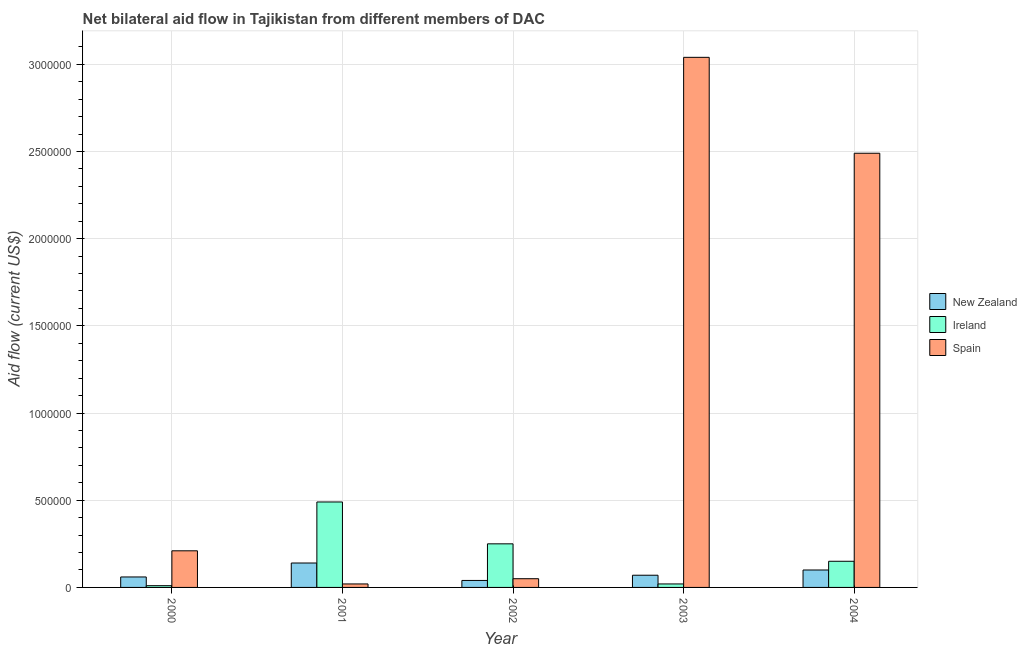Are the number of bars per tick equal to the number of legend labels?
Provide a short and direct response. Yes. Are the number of bars on each tick of the X-axis equal?
Your response must be concise. Yes. How many bars are there on the 5th tick from the right?
Your answer should be very brief. 3. What is the amount of aid provided by new zealand in 2000?
Provide a short and direct response. 6.00e+04. Across all years, what is the maximum amount of aid provided by ireland?
Provide a succinct answer. 4.90e+05. Across all years, what is the minimum amount of aid provided by spain?
Make the answer very short. 2.00e+04. In which year was the amount of aid provided by spain maximum?
Keep it short and to the point. 2003. What is the total amount of aid provided by new zealand in the graph?
Your answer should be very brief. 4.10e+05. What is the difference between the amount of aid provided by spain in 2003 and that in 2004?
Offer a terse response. 5.50e+05. What is the difference between the amount of aid provided by ireland in 2004 and the amount of aid provided by spain in 2002?
Provide a succinct answer. -1.00e+05. What is the average amount of aid provided by new zealand per year?
Your answer should be compact. 8.20e+04. In the year 2003, what is the difference between the amount of aid provided by new zealand and amount of aid provided by ireland?
Offer a very short reply. 0. What is the ratio of the amount of aid provided by spain in 2000 to that in 2004?
Ensure brevity in your answer.  0.08. Is the amount of aid provided by ireland in 2003 less than that in 2004?
Your answer should be compact. Yes. What is the difference between the highest and the lowest amount of aid provided by ireland?
Provide a succinct answer. 4.80e+05. Is the sum of the amount of aid provided by new zealand in 2002 and 2004 greater than the maximum amount of aid provided by spain across all years?
Provide a succinct answer. No. What does the 1st bar from the left in 2003 represents?
Your answer should be very brief. New Zealand. What does the 1st bar from the right in 2004 represents?
Provide a short and direct response. Spain. Is it the case that in every year, the sum of the amount of aid provided by new zealand and amount of aid provided by ireland is greater than the amount of aid provided by spain?
Your answer should be very brief. No. How many years are there in the graph?
Ensure brevity in your answer.  5. Does the graph contain any zero values?
Provide a short and direct response. No. Does the graph contain grids?
Provide a succinct answer. Yes. Where does the legend appear in the graph?
Keep it short and to the point. Center right. How are the legend labels stacked?
Offer a very short reply. Vertical. What is the title of the graph?
Ensure brevity in your answer.  Net bilateral aid flow in Tajikistan from different members of DAC. Does "Errors" appear as one of the legend labels in the graph?
Provide a short and direct response. No. What is the label or title of the X-axis?
Offer a terse response. Year. What is the label or title of the Y-axis?
Your answer should be very brief. Aid flow (current US$). What is the Aid flow (current US$) of New Zealand in 2000?
Provide a short and direct response. 6.00e+04. What is the Aid flow (current US$) of Spain in 2000?
Make the answer very short. 2.10e+05. What is the Aid flow (current US$) in New Zealand in 2001?
Ensure brevity in your answer.  1.40e+05. What is the Aid flow (current US$) of Ireland in 2001?
Give a very brief answer. 4.90e+05. What is the Aid flow (current US$) of Spain in 2001?
Your answer should be very brief. 2.00e+04. What is the Aid flow (current US$) of Ireland in 2003?
Offer a terse response. 2.00e+04. What is the Aid flow (current US$) in Spain in 2003?
Provide a short and direct response. 3.04e+06. What is the Aid flow (current US$) of New Zealand in 2004?
Your answer should be compact. 1.00e+05. What is the Aid flow (current US$) of Spain in 2004?
Keep it short and to the point. 2.49e+06. Across all years, what is the maximum Aid flow (current US$) of New Zealand?
Offer a terse response. 1.40e+05. Across all years, what is the maximum Aid flow (current US$) of Ireland?
Ensure brevity in your answer.  4.90e+05. Across all years, what is the maximum Aid flow (current US$) of Spain?
Give a very brief answer. 3.04e+06. Across all years, what is the minimum Aid flow (current US$) of New Zealand?
Your answer should be very brief. 4.00e+04. Across all years, what is the minimum Aid flow (current US$) in Spain?
Make the answer very short. 2.00e+04. What is the total Aid flow (current US$) in Ireland in the graph?
Make the answer very short. 9.20e+05. What is the total Aid flow (current US$) of Spain in the graph?
Give a very brief answer. 5.81e+06. What is the difference between the Aid flow (current US$) of New Zealand in 2000 and that in 2001?
Your answer should be very brief. -8.00e+04. What is the difference between the Aid flow (current US$) of Ireland in 2000 and that in 2001?
Provide a succinct answer. -4.80e+05. What is the difference between the Aid flow (current US$) in New Zealand in 2000 and that in 2002?
Give a very brief answer. 2.00e+04. What is the difference between the Aid flow (current US$) of Ireland in 2000 and that in 2002?
Offer a very short reply. -2.40e+05. What is the difference between the Aid flow (current US$) of New Zealand in 2000 and that in 2003?
Keep it short and to the point. -10000. What is the difference between the Aid flow (current US$) of Spain in 2000 and that in 2003?
Your answer should be very brief. -2.83e+06. What is the difference between the Aid flow (current US$) of New Zealand in 2000 and that in 2004?
Offer a terse response. -4.00e+04. What is the difference between the Aid flow (current US$) of Ireland in 2000 and that in 2004?
Your answer should be compact. -1.40e+05. What is the difference between the Aid flow (current US$) in Spain in 2000 and that in 2004?
Offer a terse response. -2.28e+06. What is the difference between the Aid flow (current US$) in New Zealand in 2001 and that in 2002?
Ensure brevity in your answer.  1.00e+05. What is the difference between the Aid flow (current US$) in Ireland in 2001 and that in 2002?
Ensure brevity in your answer.  2.40e+05. What is the difference between the Aid flow (current US$) in Spain in 2001 and that in 2002?
Offer a very short reply. -3.00e+04. What is the difference between the Aid flow (current US$) of Spain in 2001 and that in 2003?
Offer a very short reply. -3.02e+06. What is the difference between the Aid flow (current US$) in Ireland in 2001 and that in 2004?
Your answer should be compact. 3.40e+05. What is the difference between the Aid flow (current US$) of Spain in 2001 and that in 2004?
Make the answer very short. -2.47e+06. What is the difference between the Aid flow (current US$) of New Zealand in 2002 and that in 2003?
Make the answer very short. -3.00e+04. What is the difference between the Aid flow (current US$) in Spain in 2002 and that in 2003?
Offer a terse response. -2.99e+06. What is the difference between the Aid flow (current US$) of New Zealand in 2002 and that in 2004?
Give a very brief answer. -6.00e+04. What is the difference between the Aid flow (current US$) of Spain in 2002 and that in 2004?
Offer a very short reply. -2.44e+06. What is the difference between the Aid flow (current US$) in Spain in 2003 and that in 2004?
Your answer should be compact. 5.50e+05. What is the difference between the Aid flow (current US$) of New Zealand in 2000 and the Aid flow (current US$) of Ireland in 2001?
Offer a very short reply. -4.30e+05. What is the difference between the Aid flow (current US$) in New Zealand in 2000 and the Aid flow (current US$) in Spain in 2001?
Keep it short and to the point. 4.00e+04. What is the difference between the Aid flow (current US$) of New Zealand in 2000 and the Aid flow (current US$) of Ireland in 2002?
Keep it short and to the point. -1.90e+05. What is the difference between the Aid flow (current US$) of New Zealand in 2000 and the Aid flow (current US$) of Ireland in 2003?
Provide a short and direct response. 4.00e+04. What is the difference between the Aid flow (current US$) of New Zealand in 2000 and the Aid flow (current US$) of Spain in 2003?
Make the answer very short. -2.98e+06. What is the difference between the Aid flow (current US$) in Ireland in 2000 and the Aid flow (current US$) in Spain in 2003?
Provide a short and direct response. -3.03e+06. What is the difference between the Aid flow (current US$) of New Zealand in 2000 and the Aid flow (current US$) of Ireland in 2004?
Keep it short and to the point. -9.00e+04. What is the difference between the Aid flow (current US$) in New Zealand in 2000 and the Aid flow (current US$) in Spain in 2004?
Your answer should be very brief. -2.43e+06. What is the difference between the Aid flow (current US$) in Ireland in 2000 and the Aid flow (current US$) in Spain in 2004?
Ensure brevity in your answer.  -2.48e+06. What is the difference between the Aid flow (current US$) in New Zealand in 2001 and the Aid flow (current US$) in Ireland in 2002?
Offer a terse response. -1.10e+05. What is the difference between the Aid flow (current US$) in Ireland in 2001 and the Aid flow (current US$) in Spain in 2002?
Offer a very short reply. 4.40e+05. What is the difference between the Aid flow (current US$) in New Zealand in 2001 and the Aid flow (current US$) in Ireland in 2003?
Make the answer very short. 1.20e+05. What is the difference between the Aid flow (current US$) in New Zealand in 2001 and the Aid flow (current US$) in Spain in 2003?
Provide a succinct answer. -2.90e+06. What is the difference between the Aid flow (current US$) of Ireland in 2001 and the Aid flow (current US$) of Spain in 2003?
Your answer should be compact. -2.55e+06. What is the difference between the Aid flow (current US$) of New Zealand in 2001 and the Aid flow (current US$) of Ireland in 2004?
Provide a succinct answer. -10000. What is the difference between the Aid flow (current US$) in New Zealand in 2001 and the Aid flow (current US$) in Spain in 2004?
Give a very brief answer. -2.35e+06. What is the difference between the Aid flow (current US$) in Ireland in 2001 and the Aid flow (current US$) in Spain in 2004?
Provide a short and direct response. -2.00e+06. What is the difference between the Aid flow (current US$) of New Zealand in 2002 and the Aid flow (current US$) of Ireland in 2003?
Provide a short and direct response. 2.00e+04. What is the difference between the Aid flow (current US$) in New Zealand in 2002 and the Aid flow (current US$) in Spain in 2003?
Offer a terse response. -3.00e+06. What is the difference between the Aid flow (current US$) of Ireland in 2002 and the Aid flow (current US$) of Spain in 2003?
Provide a succinct answer. -2.79e+06. What is the difference between the Aid flow (current US$) in New Zealand in 2002 and the Aid flow (current US$) in Ireland in 2004?
Provide a short and direct response. -1.10e+05. What is the difference between the Aid flow (current US$) of New Zealand in 2002 and the Aid flow (current US$) of Spain in 2004?
Your answer should be very brief. -2.45e+06. What is the difference between the Aid flow (current US$) in Ireland in 2002 and the Aid flow (current US$) in Spain in 2004?
Give a very brief answer. -2.24e+06. What is the difference between the Aid flow (current US$) of New Zealand in 2003 and the Aid flow (current US$) of Spain in 2004?
Your answer should be very brief. -2.42e+06. What is the difference between the Aid flow (current US$) of Ireland in 2003 and the Aid flow (current US$) of Spain in 2004?
Keep it short and to the point. -2.47e+06. What is the average Aid flow (current US$) in New Zealand per year?
Make the answer very short. 8.20e+04. What is the average Aid flow (current US$) of Ireland per year?
Offer a very short reply. 1.84e+05. What is the average Aid flow (current US$) of Spain per year?
Offer a very short reply. 1.16e+06. In the year 2000, what is the difference between the Aid flow (current US$) of New Zealand and Aid flow (current US$) of Spain?
Make the answer very short. -1.50e+05. In the year 2001, what is the difference between the Aid flow (current US$) in New Zealand and Aid flow (current US$) in Ireland?
Your response must be concise. -3.50e+05. In the year 2001, what is the difference between the Aid flow (current US$) of Ireland and Aid flow (current US$) of Spain?
Offer a very short reply. 4.70e+05. In the year 2002, what is the difference between the Aid flow (current US$) of New Zealand and Aid flow (current US$) of Ireland?
Give a very brief answer. -2.10e+05. In the year 2003, what is the difference between the Aid flow (current US$) in New Zealand and Aid flow (current US$) in Spain?
Give a very brief answer. -2.97e+06. In the year 2003, what is the difference between the Aid flow (current US$) of Ireland and Aid flow (current US$) of Spain?
Your answer should be very brief. -3.02e+06. In the year 2004, what is the difference between the Aid flow (current US$) in New Zealand and Aid flow (current US$) in Ireland?
Your answer should be compact. -5.00e+04. In the year 2004, what is the difference between the Aid flow (current US$) of New Zealand and Aid flow (current US$) of Spain?
Your answer should be compact. -2.39e+06. In the year 2004, what is the difference between the Aid flow (current US$) in Ireland and Aid flow (current US$) in Spain?
Your response must be concise. -2.34e+06. What is the ratio of the Aid flow (current US$) of New Zealand in 2000 to that in 2001?
Your response must be concise. 0.43. What is the ratio of the Aid flow (current US$) of Ireland in 2000 to that in 2001?
Make the answer very short. 0.02. What is the ratio of the Aid flow (current US$) in New Zealand in 2000 to that in 2002?
Ensure brevity in your answer.  1.5. What is the ratio of the Aid flow (current US$) of Ireland in 2000 to that in 2002?
Your response must be concise. 0.04. What is the ratio of the Aid flow (current US$) of Spain in 2000 to that in 2003?
Give a very brief answer. 0.07. What is the ratio of the Aid flow (current US$) of Ireland in 2000 to that in 2004?
Offer a terse response. 0.07. What is the ratio of the Aid flow (current US$) of Spain in 2000 to that in 2004?
Offer a very short reply. 0.08. What is the ratio of the Aid flow (current US$) of New Zealand in 2001 to that in 2002?
Ensure brevity in your answer.  3.5. What is the ratio of the Aid flow (current US$) in Ireland in 2001 to that in 2002?
Provide a succinct answer. 1.96. What is the ratio of the Aid flow (current US$) in Spain in 2001 to that in 2002?
Offer a terse response. 0.4. What is the ratio of the Aid flow (current US$) of New Zealand in 2001 to that in 2003?
Your answer should be compact. 2. What is the ratio of the Aid flow (current US$) in Spain in 2001 to that in 2003?
Offer a very short reply. 0.01. What is the ratio of the Aid flow (current US$) in New Zealand in 2001 to that in 2004?
Keep it short and to the point. 1.4. What is the ratio of the Aid flow (current US$) of Ireland in 2001 to that in 2004?
Offer a terse response. 3.27. What is the ratio of the Aid flow (current US$) of Spain in 2001 to that in 2004?
Provide a short and direct response. 0.01. What is the ratio of the Aid flow (current US$) in Ireland in 2002 to that in 2003?
Make the answer very short. 12.5. What is the ratio of the Aid flow (current US$) in Spain in 2002 to that in 2003?
Keep it short and to the point. 0.02. What is the ratio of the Aid flow (current US$) in New Zealand in 2002 to that in 2004?
Your answer should be compact. 0.4. What is the ratio of the Aid flow (current US$) in Spain in 2002 to that in 2004?
Give a very brief answer. 0.02. What is the ratio of the Aid flow (current US$) of Ireland in 2003 to that in 2004?
Keep it short and to the point. 0.13. What is the ratio of the Aid flow (current US$) of Spain in 2003 to that in 2004?
Make the answer very short. 1.22. What is the difference between the highest and the second highest Aid flow (current US$) in New Zealand?
Your answer should be compact. 4.00e+04. What is the difference between the highest and the lowest Aid flow (current US$) of New Zealand?
Provide a short and direct response. 1.00e+05. What is the difference between the highest and the lowest Aid flow (current US$) of Spain?
Ensure brevity in your answer.  3.02e+06. 